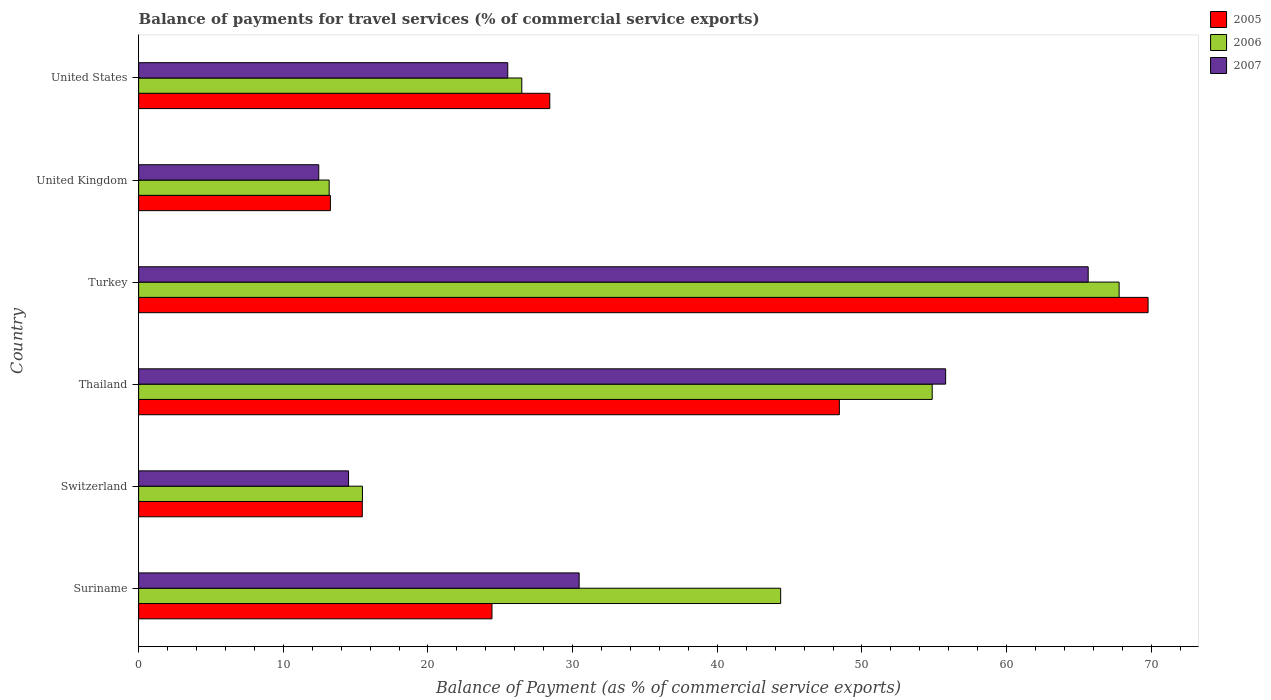Are the number of bars per tick equal to the number of legend labels?
Your answer should be very brief. Yes. How many bars are there on the 4th tick from the bottom?
Your answer should be very brief. 3. What is the label of the 5th group of bars from the top?
Provide a short and direct response. Switzerland. What is the balance of payments for travel services in 2006 in Suriname?
Your answer should be very brief. 44.38. Across all countries, what is the maximum balance of payments for travel services in 2006?
Ensure brevity in your answer.  67.78. Across all countries, what is the minimum balance of payments for travel services in 2007?
Keep it short and to the point. 12.45. What is the total balance of payments for travel services in 2006 in the graph?
Offer a terse response. 222.15. What is the difference between the balance of payments for travel services in 2006 in Turkey and that in United Kingdom?
Your answer should be very brief. 54.61. What is the difference between the balance of payments for travel services in 2007 in Suriname and the balance of payments for travel services in 2005 in Switzerland?
Keep it short and to the point. 14.99. What is the average balance of payments for travel services in 2005 per country?
Provide a succinct answer. 33.3. What is the difference between the balance of payments for travel services in 2007 and balance of payments for travel services in 2006 in Suriname?
Offer a very short reply. -13.93. What is the ratio of the balance of payments for travel services in 2006 in Switzerland to that in United States?
Keep it short and to the point. 0.58. Is the balance of payments for travel services in 2007 in Switzerland less than that in United States?
Your response must be concise. Yes. Is the difference between the balance of payments for travel services in 2007 in Suriname and Thailand greater than the difference between the balance of payments for travel services in 2006 in Suriname and Thailand?
Provide a short and direct response. No. What is the difference between the highest and the second highest balance of payments for travel services in 2007?
Your answer should be very brief. 9.85. What is the difference between the highest and the lowest balance of payments for travel services in 2005?
Provide a succinct answer. 56.52. What does the 1st bar from the bottom in United States represents?
Your answer should be compact. 2005. Is it the case that in every country, the sum of the balance of payments for travel services in 2007 and balance of payments for travel services in 2005 is greater than the balance of payments for travel services in 2006?
Make the answer very short. Yes. What is the difference between two consecutive major ticks on the X-axis?
Give a very brief answer. 10. Are the values on the major ticks of X-axis written in scientific E-notation?
Offer a very short reply. No. Does the graph contain grids?
Make the answer very short. No. Where does the legend appear in the graph?
Give a very brief answer. Top right. How many legend labels are there?
Your answer should be very brief. 3. What is the title of the graph?
Provide a short and direct response. Balance of payments for travel services (% of commercial service exports). Does "2003" appear as one of the legend labels in the graph?
Ensure brevity in your answer.  No. What is the label or title of the X-axis?
Provide a short and direct response. Balance of Payment (as % of commercial service exports). What is the Balance of Payment (as % of commercial service exports) in 2005 in Suriname?
Your answer should be compact. 24.42. What is the Balance of Payment (as % of commercial service exports) in 2006 in Suriname?
Provide a succinct answer. 44.38. What is the Balance of Payment (as % of commercial service exports) of 2007 in Suriname?
Your answer should be compact. 30.45. What is the Balance of Payment (as % of commercial service exports) of 2005 in Switzerland?
Provide a short and direct response. 15.46. What is the Balance of Payment (as % of commercial service exports) of 2006 in Switzerland?
Your answer should be compact. 15.47. What is the Balance of Payment (as % of commercial service exports) of 2007 in Switzerland?
Your response must be concise. 14.51. What is the Balance of Payment (as % of commercial service exports) of 2005 in Thailand?
Provide a short and direct response. 48.44. What is the Balance of Payment (as % of commercial service exports) of 2006 in Thailand?
Provide a short and direct response. 54.86. What is the Balance of Payment (as % of commercial service exports) in 2007 in Thailand?
Keep it short and to the point. 55.79. What is the Balance of Payment (as % of commercial service exports) of 2005 in Turkey?
Offer a very short reply. 69.78. What is the Balance of Payment (as % of commercial service exports) of 2006 in Turkey?
Provide a succinct answer. 67.78. What is the Balance of Payment (as % of commercial service exports) in 2007 in Turkey?
Provide a succinct answer. 65.64. What is the Balance of Payment (as % of commercial service exports) in 2005 in United Kingdom?
Ensure brevity in your answer.  13.26. What is the Balance of Payment (as % of commercial service exports) of 2006 in United Kingdom?
Provide a succinct answer. 13.17. What is the Balance of Payment (as % of commercial service exports) in 2007 in United Kingdom?
Provide a succinct answer. 12.45. What is the Balance of Payment (as % of commercial service exports) of 2005 in United States?
Provide a short and direct response. 28.42. What is the Balance of Payment (as % of commercial service exports) in 2006 in United States?
Your response must be concise. 26.49. What is the Balance of Payment (as % of commercial service exports) of 2007 in United States?
Offer a very short reply. 25.52. Across all countries, what is the maximum Balance of Payment (as % of commercial service exports) of 2005?
Your answer should be compact. 69.78. Across all countries, what is the maximum Balance of Payment (as % of commercial service exports) of 2006?
Your response must be concise. 67.78. Across all countries, what is the maximum Balance of Payment (as % of commercial service exports) of 2007?
Your response must be concise. 65.64. Across all countries, what is the minimum Balance of Payment (as % of commercial service exports) of 2005?
Give a very brief answer. 13.26. Across all countries, what is the minimum Balance of Payment (as % of commercial service exports) of 2006?
Give a very brief answer. 13.17. Across all countries, what is the minimum Balance of Payment (as % of commercial service exports) in 2007?
Your answer should be very brief. 12.45. What is the total Balance of Payment (as % of commercial service exports) in 2005 in the graph?
Give a very brief answer. 199.78. What is the total Balance of Payment (as % of commercial service exports) of 2006 in the graph?
Your response must be concise. 222.15. What is the total Balance of Payment (as % of commercial service exports) in 2007 in the graph?
Provide a succinct answer. 204.36. What is the difference between the Balance of Payment (as % of commercial service exports) of 2005 in Suriname and that in Switzerland?
Give a very brief answer. 8.96. What is the difference between the Balance of Payment (as % of commercial service exports) in 2006 in Suriname and that in Switzerland?
Your answer should be compact. 28.91. What is the difference between the Balance of Payment (as % of commercial service exports) of 2007 in Suriname and that in Switzerland?
Your answer should be compact. 15.94. What is the difference between the Balance of Payment (as % of commercial service exports) of 2005 in Suriname and that in Thailand?
Your answer should be compact. -24.01. What is the difference between the Balance of Payment (as % of commercial service exports) of 2006 in Suriname and that in Thailand?
Provide a short and direct response. -10.48. What is the difference between the Balance of Payment (as % of commercial service exports) in 2007 in Suriname and that in Thailand?
Offer a very short reply. -25.33. What is the difference between the Balance of Payment (as % of commercial service exports) of 2005 in Suriname and that in Turkey?
Your answer should be very brief. -45.36. What is the difference between the Balance of Payment (as % of commercial service exports) of 2006 in Suriname and that in Turkey?
Your answer should be compact. -23.4. What is the difference between the Balance of Payment (as % of commercial service exports) in 2007 in Suriname and that in Turkey?
Offer a terse response. -35.19. What is the difference between the Balance of Payment (as % of commercial service exports) of 2005 in Suriname and that in United Kingdom?
Ensure brevity in your answer.  11.17. What is the difference between the Balance of Payment (as % of commercial service exports) in 2006 in Suriname and that in United Kingdom?
Your answer should be compact. 31.21. What is the difference between the Balance of Payment (as % of commercial service exports) of 2007 in Suriname and that in United Kingdom?
Offer a terse response. 18. What is the difference between the Balance of Payment (as % of commercial service exports) of 2005 in Suriname and that in United States?
Provide a succinct answer. -4. What is the difference between the Balance of Payment (as % of commercial service exports) in 2006 in Suriname and that in United States?
Provide a short and direct response. 17.9. What is the difference between the Balance of Payment (as % of commercial service exports) of 2007 in Suriname and that in United States?
Provide a succinct answer. 4.94. What is the difference between the Balance of Payment (as % of commercial service exports) in 2005 in Switzerland and that in Thailand?
Your response must be concise. -32.98. What is the difference between the Balance of Payment (as % of commercial service exports) in 2006 in Switzerland and that in Thailand?
Provide a succinct answer. -39.39. What is the difference between the Balance of Payment (as % of commercial service exports) in 2007 in Switzerland and that in Thailand?
Offer a terse response. -41.28. What is the difference between the Balance of Payment (as % of commercial service exports) of 2005 in Switzerland and that in Turkey?
Your answer should be compact. -54.32. What is the difference between the Balance of Payment (as % of commercial service exports) of 2006 in Switzerland and that in Turkey?
Ensure brevity in your answer.  -52.31. What is the difference between the Balance of Payment (as % of commercial service exports) in 2007 in Switzerland and that in Turkey?
Provide a short and direct response. -51.13. What is the difference between the Balance of Payment (as % of commercial service exports) of 2005 in Switzerland and that in United Kingdom?
Ensure brevity in your answer.  2.21. What is the difference between the Balance of Payment (as % of commercial service exports) of 2006 in Switzerland and that in United Kingdom?
Provide a succinct answer. 2.3. What is the difference between the Balance of Payment (as % of commercial service exports) in 2007 in Switzerland and that in United Kingdom?
Offer a terse response. 2.06. What is the difference between the Balance of Payment (as % of commercial service exports) of 2005 in Switzerland and that in United States?
Keep it short and to the point. -12.96. What is the difference between the Balance of Payment (as % of commercial service exports) in 2006 in Switzerland and that in United States?
Give a very brief answer. -11.01. What is the difference between the Balance of Payment (as % of commercial service exports) in 2007 in Switzerland and that in United States?
Provide a succinct answer. -11.01. What is the difference between the Balance of Payment (as % of commercial service exports) in 2005 in Thailand and that in Turkey?
Offer a terse response. -21.34. What is the difference between the Balance of Payment (as % of commercial service exports) in 2006 in Thailand and that in Turkey?
Make the answer very short. -12.92. What is the difference between the Balance of Payment (as % of commercial service exports) of 2007 in Thailand and that in Turkey?
Your answer should be compact. -9.85. What is the difference between the Balance of Payment (as % of commercial service exports) in 2005 in Thailand and that in United Kingdom?
Offer a terse response. 35.18. What is the difference between the Balance of Payment (as % of commercial service exports) in 2006 in Thailand and that in United Kingdom?
Keep it short and to the point. 41.69. What is the difference between the Balance of Payment (as % of commercial service exports) of 2007 in Thailand and that in United Kingdom?
Your response must be concise. 43.34. What is the difference between the Balance of Payment (as % of commercial service exports) of 2005 in Thailand and that in United States?
Ensure brevity in your answer.  20.02. What is the difference between the Balance of Payment (as % of commercial service exports) in 2006 in Thailand and that in United States?
Your answer should be very brief. 28.37. What is the difference between the Balance of Payment (as % of commercial service exports) in 2007 in Thailand and that in United States?
Offer a terse response. 30.27. What is the difference between the Balance of Payment (as % of commercial service exports) in 2005 in Turkey and that in United Kingdom?
Keep it short and to the point. 56.52. What is the difference between the Balance of Payment (as % of commercial service exports) of 2006 in Turkey and that in United Kingdom?
Offer a very short reply. 54.61. What is the difference between the Balance of Payment (as % of commercial service exports) in 2007 in Turkey and that in United Kingdom?
Give a very brief answer. 53.19. What is the difference between the Balance of Payment (as % of commercial service exports) of 2005 in Turkey and that in United States?
Offer a very short reply. 41.36. What is the difference between the Balance of Payment (as % of commercial service exports) of 2006 in Turkey and that in United States?
Ensure brevity in your answer.  41.29. What is the difference between the Balance of Payment (as % of commercial service exports) in 2007 in Turkey and that in United States?
Offer a terse response. 40.12. What is the difference between the Balance of Payment (as % of commercial service exports) of 2005 in United Kingdom and that in United States?
Provide a short and direct response. -15.17. What is the difference between the Balance of Payment (as % of commercial service exports) of 2006 in United Kingdom and that in United States?
Your response must be concise. -13.32. What is the difference between the Balance of Payment (as % of commercial service exports) of 2007 in United Kingdom and that in United States?
Your answer should be very brief. -13.06. What is the difference between the Balance of Payment (as % of commercial service exports) of 2005 in Suriname and the Balance of Payment (as % of commercial service exports) of 2006 in Switzerland?
Your response must be concise. 8.95. What is the difference between the Balance of Payment (as % of commercial service exports) in 2005 in Suriname and the Balance of Payment (as % of commercial service exports) in 2007 in Switzerland?
Provide a short and direct response. 9.91. What is the difference between the Balance of Payment (as % of commercial service exports) of 2006 in Suriname and the Balance of Payment (as % of commercial service exports) of 2007 in Switzerland?
Give a very brief answer. 29.87. What is the difference between the Balance of Payment (as % of commercial service exports) in 2005 in Suriname and the Balance of Payment (as % of commercial service exports) in 2006 in Thailand?
Your response must be concise. -30.43. What is the difference between the Balance of Payment (as % of commercial service exports) of 2005 in Suriname and the Balance of Payment (as % of commercial service exports) of 2007 in Thailand?
Offer a very short reply. -31.36. What is the difference between the Balance of Payment (as % of commercial service exports) in 2006 in Suriname and the Balance of Payment (as % of commercial service exports) in 2007 in Thailand?
Provide a short and direct response. -11.4. What is the difference between the Balance of Payment (as % of commercial service exports) of 2005 in Suriname and the Balance of Payment (as % of commercial service exports) of 2006 in Turkey?
Your response must be concise. -43.35. What is the difference between the Balance of Payment (as % of commercial service exports) of 2005 in Suriname and the Balance of Payment (as % of commercial service exports) of 2007 in Turkey?
Give a very brief answer. -41.21. What is the difference between the Balance of Payment (as % of commercial service exports) of 2006 in Suriname and the Balance of Payment (as % of commercial service exports) of 2007 in Turkey?
Keep it short and to the point. -21.26. What is the difference between the Balance of Payment (as % of commercial service exports) in 2005 in Suriname and the Balance of Payment (as % of commercial service exports) in 2006 in United Kingdom?
Keep it short and to the point. 11.25. What is the difference between the Balance of Payment (as % of commercial service exports) of 2005 in Suriname and the Balance of Payment (as % of commercial service exports) of 2007 in United Kingdom?
Your answer should be very brief. 11.97. What is the difference between the Balance of Payment (as % of commercial service exports) of 2006 in Suriname and the Balance of Payment (as % of commercial service exports) of 2007 in United Kingdom?
Provide a succinct answer. 31.93. What is the difference between the Balance of Payment (as % of commercial service exports) in 2005 in Suriname and the Balance of Payment (as % of commercial service exports) in 2006 in United States?
Your answer should be very brief. -2.06. What is the difference between the Balance of Payment (as % of commercial service exports) in 2005 in Suriname and the Balance of Payment (as % of commercial service exports) in 2007 in United States?
Make the answer very short. -1.09. What is the difference between the Balance of Payment (as % of commercial service exports) in 2006 in Suriname and the Balance of Payment (as % of commercial service exports) in 2007 in United States?
Offer a terse response. 18.87. What is the difference between the Balance of Payment (as % of commercial service exports) of 2005 in Switzerland and the Balance of Payment (as % of commercial service exports) of 2006 in Thailand?
Offer a terse response. -39.4. What is the difference between the Balance of Payment (as % of commercial service exports) in 2005 in Switzerland and the Balance of Payment (as % of commercial service exports) in 2007 in Thailand?
Keep it short and to the point. -40.33. What is the difference between the Balance of Payment (as % of commercial service exports) in 2006 in Switzerland and the Balance of Payment (as % of commercial service exports) in 2007 in Thailand?
Your answer should be very brief. -40.31. What is the difference between the Balance of Payment (as % of commercial service exports) in 2005 in Switzerland and the Balance of Payment (as % of commercial service exports) in 2006 in Turkey?
Your answer should be compact. -52.32. What is the difference between the Balance of Payment (as % of commercial service exports) of 2005 in Switzerland and the Balance of Payment (as % of commercial service exports) of 2007 in Turkey?
Ensure brevity in your answer.  -50.18. What is the difference between the Balance of Payment (as % of commercial service exports) in 2006 in Switzerland and the Balance of Payment (as % of commercial service exports) in 2007 in Turkey?
Your response must be concise. -50.17. What is the difference between the Balance of Payment (as % of commercial service exports) of 2005 in Switzerland and the Balance of Payment (as % of commercial service exports) of 2006 in United Kingdom?
Ensure brevity in your answer.  2.29. What is the difference between the Balance of Payment (as % of commercial service exports) of 2005 in Switzerland and the Balance of Payment (as % of commercial service exports) of 2007 in United Kingdom?
Offer a very short reply. 3.01. What is the difference between the Balance of Payment (as % of commercial service exports) in 2006 in Switzerland and the Balance of Payment (as % of commercial service exports) in 2007 in United Kingdom?
Provide a short and direct response. 3.02. What is the difference between the Balance of Payment (as % of commercial service exports) of 2005 in Switzerland and the Balance of Payment (as % of commercial service exports) of 2006 in United States?
Provide a short and direct response. -11.03. What is the difference between the Balance of Payment (as % of commercial service exports) of 2005 in Switzerland and the Balance of Payment (as % of commercial service exports) of 2007 in United States?
Ensure brevity in your answer.  -10.05. What is the difference between the Balance of Payment (as % of commercial service exports) in 2006 in Switzerland and the Balance of Payment (as % of commercial service exports) in 2007 in United States?
Your answer should be compact. -10.04. What is the difference between the Balance of Payment (as % of commercial service exports) in 2005 in Thailand and the Balance of Payment (as % of commercial service exports) in 2006 in Turkey?
Your answer should be compact. -19.34. What is the difference between the Balance of Payment (as % of commercial service exports) of 2005 in Thailand and the Balance of Payment (as % of commercial service exports) of 2007 in Turkey?
Ensure brevity in your answer.  -17.2. What is the difference between the Balance of Payment (as % of commercial service exports) in 2006 in Thailand and the Balance of Payment (as % of commercial service exports) in 2007 in Turkey?
Make the answer very short. -10.78. What is the difference between the Balance of Payment (as % of commercial service exports) in 2005 in Thailand and the Balance of Payment (as % of commercial service exports) in 2006 in United Kingdom?
Offer a very short reply. 35.27. What is the difference between the Balance of Payment (as % of commercial service exports) in 2005 in Thailand and the Balance of Payment (as % of commercial service exports) in 2007 in United Kingdom?
Make the answer very short. 35.99. What is the difference between the Balance of Payment (as % of commercial service exports) of 2006 in Thailand and the Balance of Payment (as % of commercial service exports) of 2007 in United Kingdom?
Your response must be concise. 42.41. What is the difference between the Balance of Payment (as % of commercial service exports) of 2005 in Thailand and the Balance of Payment (as % of commercial service exports) of 2006 in United States?
Your response must be concise. 21.95. What is the difference between the Balance of Payment (as % of commercial service exports) of 2005 in Thailand and the Balance of Payment (as % of commercial service exports) of 2007 in United States?
Offer a very short reply. 22.92. What is the difference between the Balance of Payment (as % of commercial service exports) in 2006 in Thailand and the Balance of Payment (as % of commercial service exports) in 2007 in United States?
Offer a very short reply. 29.34. What is the difference between the Balance of Payment (as % of commercial service exports) in 2005 in Turkey and the Balance of Payment (as % of commercial service exports) in 2006 in United Kingdom?
Give a very brief answer. 56.61. What is the difference between the Balance of Payment (as % of commercial service exports) of 2005 in Turkey and the Balance of Payment (as % of commercial service exports) of 2007 in United Kingdom?
Ensure brevity in your answer.  57.33. What is the difference between the Balance of Payment (as % of commercial service exports) of 2006 in Turkey and the Balance of Payment (as % of commercial service exports) of 2007 in United Kingdom?
Your answer should be compact. 55.33. What is the difference between the Balance of Payment (as % of commercial service exports) of 2005 in Turkey and the Balance of Payment (as % of commercial service exports) of 2006 in United States?
Offer a very short reply. 43.29. What is the difference between the Balance of Payment (as % of commercial service exports) in 2005 in Turkey and the Balance of Payment (as % of commercial service exports) in 2007 in United States?
Your response must be concise. 44.26. What is the difference between the Balance of Payment (as % of commercial service exports) of 2006 in Turkey and the Balance of Payment (as % of commercial service exports) of 2007 in United States?
Keep it short and to the point. 42.26. What is the difference between the Balance of Payment (as % of commercial service exports) in 2005 in United Kingdom and the Balance of Payment (as % of commercial service exports) in 2006 in United States?
Offer a terse response. -13.23. What is the difference between the Balance of Payment (as % of commercial service exports) in 2005 in United Kingdom and the Balance of Payment (as % of commercial service exports) in 2007 in United States?
Your answer should be very brief. -12.26. What is the difference between the Balance of Payment (as % of commercial service exports) of 2006 in United Kingdom and the Balance of Payment (as % of commercial service exports) of 2007 in United States?
Your answer should be compact. -12.34. What is the average Balance of Payment (as % of commercial service exports) of 2005 per country?
Keep it short and to the point. 33.3. What is the average Balance of Payment (as % of commercial service exports) in 2006 per country?
Provide a short and direct response. 37.02. What is the average Balance of Payment (as % of commercial service exports) in 2007 per country?
Ensure brevity in your answer.  34.06. What is the difference between the Balance of Payment (as % of commercial service exports) of 2005 and Balance of Payment (as % of commercial service exports) of 2006 in Suriname?
Offer a very short reply. -19.96. What is the difference between the Balance of Payment (as % of commercial service exports) of 2005 and Balance of Payment (as % of commercial service exports) of 2007 in Suriname?
Offer a very short reply. -6.03. What is the difference between the Balance of Payment (as % of commercial service exports) in 2006 and Balance of Payment (as % of commercial service exports) in 2007 in Suriname?
Your response must be concise. 13.93. What is the difference between the Balance of Payment (as % of commercial service exports) of 2005 and Balance of Payment (as % of commercial service exports) of 2006 in Switzerland?
Your answer should be compact. -0.01. What is the difference between the Balance of Payment (as % of commercial service exports) of 2005 and Balance of Payment (as % of commercial service exports) of 2007 in Switzerland?
Make the answer very short. 0.95. What is the difference between the Balance of Payment (as % of commercial service exports) of 2006 and Balance of Payment (as % of commercial service exports) of 2007 in Switzerland?
Offer a terse response. 0.96. What is the difference between the Balance of Payment (as % of commercial service exports) in 2005 and Balance of Payment (as % of commercial service exports) in 2006 in Thailand?
Give a very brief answer. -6.42. What is the difference between the Balance of Payment (as % of commercial service exports) of 2005 and Balance of Payment (as % of commercial service exports) of 2007 in Thailand?
Provide a short and direct response. -7.35. What is the difference between the Balance of Payment (as % of commercial service exports) in 2006 and Balance of Payment (as % of commercial service exports) in 2007 in Thailand?
Your response must be concise. -0.93. What is the difference between the Balance of Payment (as % of commercial service exports) of 2005 and Balance of Payment (as % of commercial service exports) of 2006 in Turkey?
Your answer should be very brief. 2. What is the difference between the Balance of Payment (as % of commercial service exports) of 2005 and Balance of Payment (as % of commercial service exports) of 2007 in Turkey?
Provide a short and direct response. 4.14. What is the difference between the Balance of Payment (as % of commercial service exports) in 2006 and Balance of Payment (as % of commercial service exports) in 2007 in Turkey?
Offer a very short reply. 2.14. What is the difference between the Balance of Payment (as % of commercial service exports) in 2005 and Balance of Payment (as % of commercial service exports) in 2006 in United Kingdom?
Provide a succinct answer. 0.08. What is the difference between the Balance of Payment (as % of commercial service exports) of 2005 and Balance of Payment (as % of commercial service exports) of 2007 in United Kingdom?
Offer a terse response. 0.8. What is the difference between the Balance of Payment (as % of commercial service exports) of 2006 and Balance of Payment (as % of commercial service exports) of 2007 in United Kingdom?
Your answer should be very brief. 0.72. What is the difference between the Balance of Payment (as % of commercial service exports) of 2005 and Balance of Payment (as % of commercial service exports) of 2006 in United States?
Your response must be concise. 1.93. What is the difference between the Balance of Payment (as % of commercial service exports) in 2005 and Balance of Payment (as % of commercial service exports) in 2007 in United States?
Give a very brief answer. 2.91. What is the difference between the Balance of Payment (as % of commercial service exports) in 2006 and Balance of Payment (as % of commercial service exports) in 2007 in United States?
Make the answer very short. 0.97. What is the ratio of the Balance of Payment (as % of commercial service exports) in 2005 in Suriname to that in Switzerland?
Your answer should be compact. 1.58. What is the ratio of the Balance of Payment (as % of commercial service exports) in 2006 in Suriname to that in Switzerland?
Your answer should be very brief. 2.87. What is the ratio of the Balance of Payment (as % of commercial service exports) of 2007 in Suriname to that in Switzerland?
Provide a succinct answer. 2.1. What is the ratio of the Balance of Payment (as % of commercial service exports) of 2005 in Suriname to that in Thailand?
Provide a succinct answer. 0.5. What is the ratio of the Balance of Payment (as % of commercial service exports) in 2006 in Suriname to that in Thailand?
Your answer should be very brief. 0.81. What is the ratio of the Balance of Payment (as % of commercial service exports) of 2007 in Suriname to that in Thailand?
Your answer should be very brief. 0.55. What is the ratio of the Balance of Payment (as % of commercial service exports) of 2006 in Suriname to that in Turkey?
Keep it short and to the point. 0.65. What is the ratio of the Balance of Payment (as % of commercial service exports) in 2007 in Suriname to that in Turkey?
Make the answer very short. 0.46. What is the ratio of the Balance of Payment (as % of commercial service exports) of 2005 in Suriname to that in United Kingdom?
Ensure brevity in your answer.  1.84. What is the ratio of the Balance of Payment (as % of commercial service exports) in 2006 in Suriname to that in United Kingdom?
Provide a succinct answer. 3.37. What is the ratio of the Balance of Payment (as % of commercial service exports) in 2007 in Suriname to that in United Kingdom?
Make the answer very short. 2.45. What is the ratio of the Balance of Payment (as % of commercial service exports) in 2005 in Suriname to that in United States?
Make the answer very short. 0.86. What is the ratio of the Balance of Payment (as % of commercial service exports) in 2006 in Suriname to that in United States?
Ensure brevity in your answer.  1.68. What is the ratio of the Balance of Payment (as % of commercial service exports) of 2007 in Suriname to that in United States?
Offer a very short reply. 1.19. What is the ratio of the Balance of Payment (as % of commercial service exports) of 2005 in Switzerland to that in Thailand?
Provide a short and direct response. 0.32. What is the ratio of the Balance of Payment (as % of commercial service exports) in 2006 in Switzerland to that in Thailand?
Offer a very short reply. 0.28. What is the ratio of the Balance of Payment (as % of commercial service exports) in 2007 in Switzerland to that in Thailand?
Your response must be concise. 0.26. What is the ratio of the Balance of Payment (as % of commercial service exports) of 2005 in Switzerland to that in Turkey?
Your answer should be very brief. 0.22. What is the ratio of the Balance of Payment (as % of commercial service exports) of 2006 in Switzerland to that in Turkey?
Offer a very short reply. 0.23. What is the ratio of the Balance of Payment (as % of commercial service exports) of 2007 in Switzerland to that in Turkey?
Make the answer very short. 0.22. What is the ratio of the Balance of Payment (as % of commercial service exports) of 2005 in Switzerland to that in United Kingdom?
Provide a succinct answer. 1.17. What is the ratio of the Balance of Payment (as % of commercial service exports) in 2006 in Switzerland to that in United Kingdom?
Make the answer very short. 1.17. What is the ratio of the Balance of Payment (as % of commercial service exports) of 2007 in Switzerland to that in United Kingdom?
Provide a short and direct response. 1.17. What is the ratio of the Balance of Payment (as % of commercial service exports) of 2005 in Switzerland to that in United States?
Your response must be concise. 0.54. What is the ratio of the Balance of Payment (as % of commercial service exports) in 2006 in Switzerland to that in United States?
Make the answer very short. 0.58. What is the ratio of the Balance of Payment (as % of commercial service exports) of 2007 in Switzerland to that in United States?
Make the answer very short. 0.57. What is the ratio of the Balance of Payment (as % of commercial service exports) in 2005 in Thailand to that in Turkey?
Provide a short and direct response. 0.69. What is the ratio of the Balance of Payment (as % of commercial service exports) in 2006 in Thailand to that in Turkey?
Offer a terse response. 0.81. What is the ratio of the Balance of Payment (as % of commercial service exports) in 2007 in Thailand to that in Turkey?
Offer a terse response. 0.85. What is the ratio of the Balance of Payment (as % of commercial service exports) in 2005 in Thailand to that in United Kingdom?
Provide a succinct answer. 3.65. What is the ratio of the Balance of Payment (as % of commercial service exports) of 2006 in Thailand to that in United Kingdom?
Offer a very short reply. 4.16. What is the ratio of the Balance of Payment (as % of commercial service exports) in 2007 in Thailand to that in United Kingdom?
Offer a very short reply. 4.48. What is the ratio of the Balance of Payment (as % of commercial service exports) of 2005 in Thailand to that in United States?
Your answer should be very brief. 1.7. What is the ratio of the Balance of Payment (as % of commercial service exports) of 2006 in Thailand to that in United States?
Give a very brief answer. 2.07. What is the ratio of the Balance of Payment (as % of commercial service exports) of 2007 in Thailand to that in United States?
Provide a succinct answer. 2.19. What is the ratio of the Balance of Payment (as % of commercial service exports) in 2005 in Turkey to that in United Kingdom?
Offer a terse response. 5.26. What is the ratio of the Balance of Payment (as % of commercial service exports) of 2006 in Turkey to that in United Kingdom?
Offer a very short reply. 5.15. What is the ratio of the Balance of Payment (as % of commercial service exports) in 2007 in Turkey to that in United Kingdom?
Offer a very short reply. 5.27. What is the ratio of the Balance of Payment (as % of commercial service exports) of 2005 in Turkey to that in United States?
Provide a short and direct response. 2.46. What is the ratio of the Balance of Payment (as % of commercial service exports) in 2006 in Turkey to that in United States?
Offer a terse response. 2.56. What is the ratio of the Balance of Payment (as % of commercial service exports) of 2007 in Turkey to that in United States?
Your answer should be compact. 2.57. What is the ratio of the Balance of Payment (as % of commercial service exports) in 2005 in United Kingdom to that in United States?
Offer a very short reply. 0.47. What is the ratio of the Balance of Payment (as % of commercial service exports) in 2006 in United Kingdom to that in United States?
Offer a very short reply. 0.5. What is the ratio of the Balance of Payment (as % of commercial service exports) of 2007 in United Kingdom to that in United States?
Offer a terse response. 0.49. What is the difference between the highest and the second highest Balance of Payment (as % of commercial service exports) of 2005?
Keep it short and to the point. 21.34. What is the difference between the highest and the second highest Balance of Payment (as % of commercial service exports) of 2006?
Your response must be concise. 12.92. What is the difference between the highest and the second highest Balance of Payment (as % of commercial service exports) of 2007?
Ensure brevity in your answer.  9.85. What is the difference between the highest and the lowest Balance of Payment (as % of commercial service exports) of 2005?
Your answer should be compact. 56.52. What is the difference between the highest and the lowest Balance of Payment (as % of commercial service exports) in 2006?
Offer a very short reply. 54.61. What is the difference between the highest and the lowest Balance of Payment (as % of commercial service exports) in 2007?
Your answer should be very brief. 53.19. 